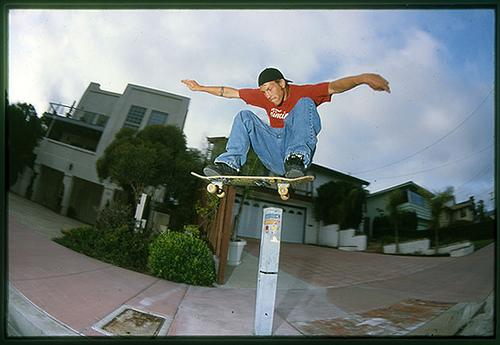What is the color of the skateboard's wheels and what is the man's shirt's color? The skateboard has yellow or light-colored wheels, and the man's shirt is red. What is the general mood or sentiment of the image based on its content? The image has a dynamic and adventurous sentiment, showcasing an exciting moment of a man successfully performing a skateboard trick. What is the primary action taking place in the image involving a man? A man is performing a skateboard trick in mid-air over a concrete post. Mention a notable feature on the man's body and explain what he is wearing. The man has a tattoo on his right elbow and is wearing a red shirt, black cap, blue faded jeans, and black tennis shoes. Assess the quality of the image in terms of focus, composition, and details. The image is of good quality, considering the sharpness of focus, comprehensive composition, and attention to details in presenting various objects in the scene. Can you count how many different objects are present in the image? There are at least 30 different objects in the image, including the man, skateboard, objects in the background, and various clothing items. Describe the type of environment the man with a skateboard is in. The man is in an urban environment with a brick sidewalk, white buildings, garage doors, balconies, and a black metal fence. Identify the type of vegetation present in the image and its location. There is a green shrub growing and a bush at the side of a sidewalk in the image. List three objects found in the background of the image. A white garage door, a white building with a balcony, and a tree in bloom are in the background. How does the man appear to interact with other objects in the scene? The man is jumping over a concrete post on a skateboard and appears to be the main focus of the scene, while other objects play supporting roles. 